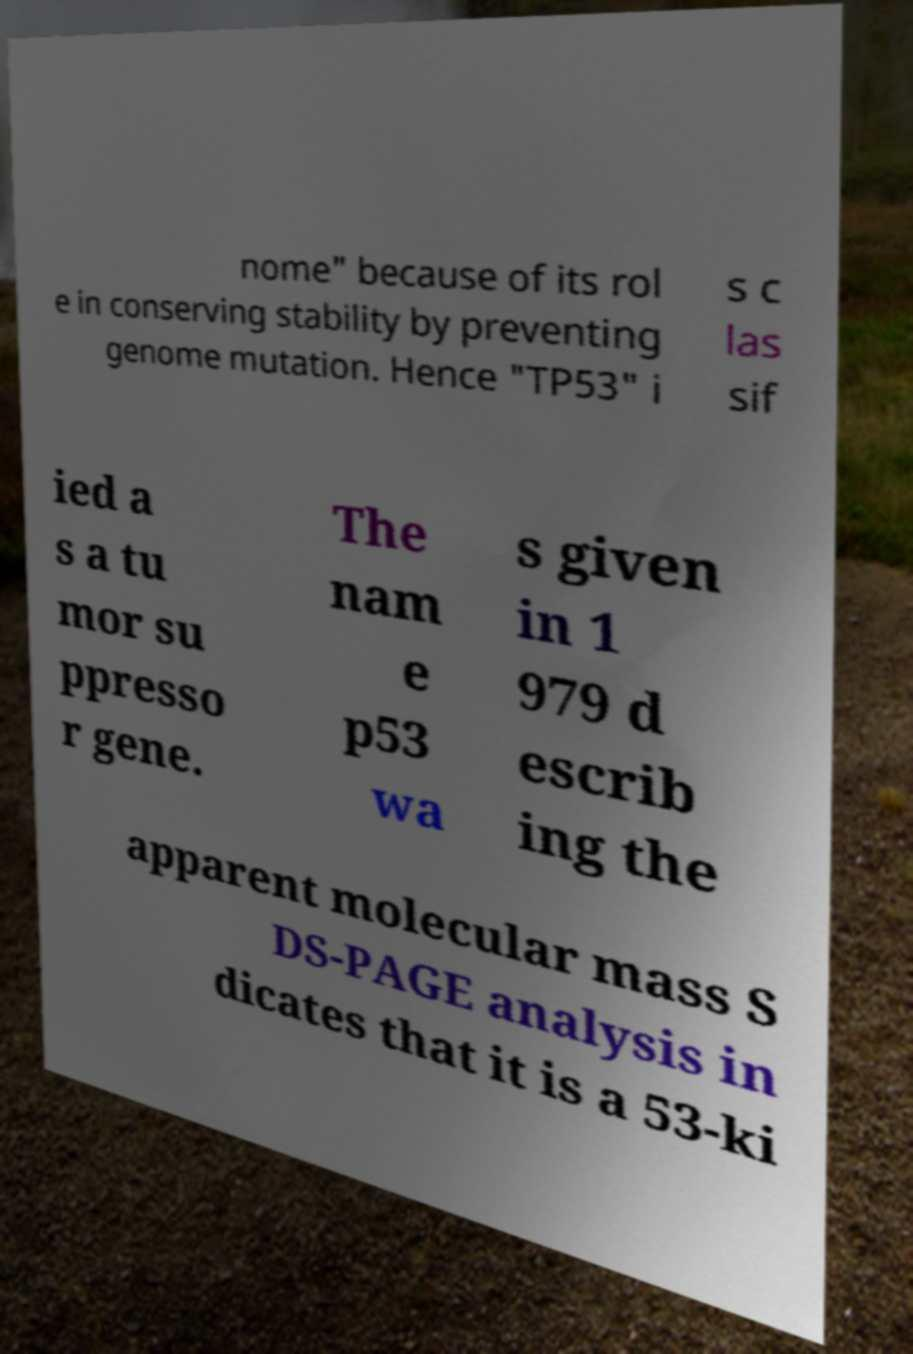Please identify and transcribe the text found in this image. nome" because of its rol e in conserving stability by preventing genome mutation. Hence "TP53" i s c las sif ied a s a tu mor su ppresso r gene. The nam e p53 wa s given in 1 979 d escrib ing the apparent molecular mass S DS-PAGE analysis in dicates that it is a 53-ki 